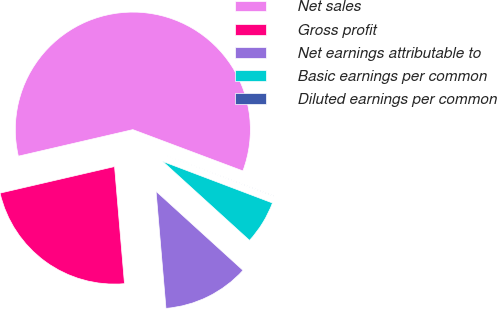Convert chart to OTSL. <chart><loc_0><loc_0><loc_500><loc_500><pie_chart><fcel>Net sales<fcel>Gross profit<fcel>Net earnings attributable to<fcel>Basic earnings per common<fcel>Diluted earnings per common<nl><fcel>59.34%<fcel>22.72%<fcel>11.91%<fcel>5.98%<fcel>0.05%<nl></chart> 